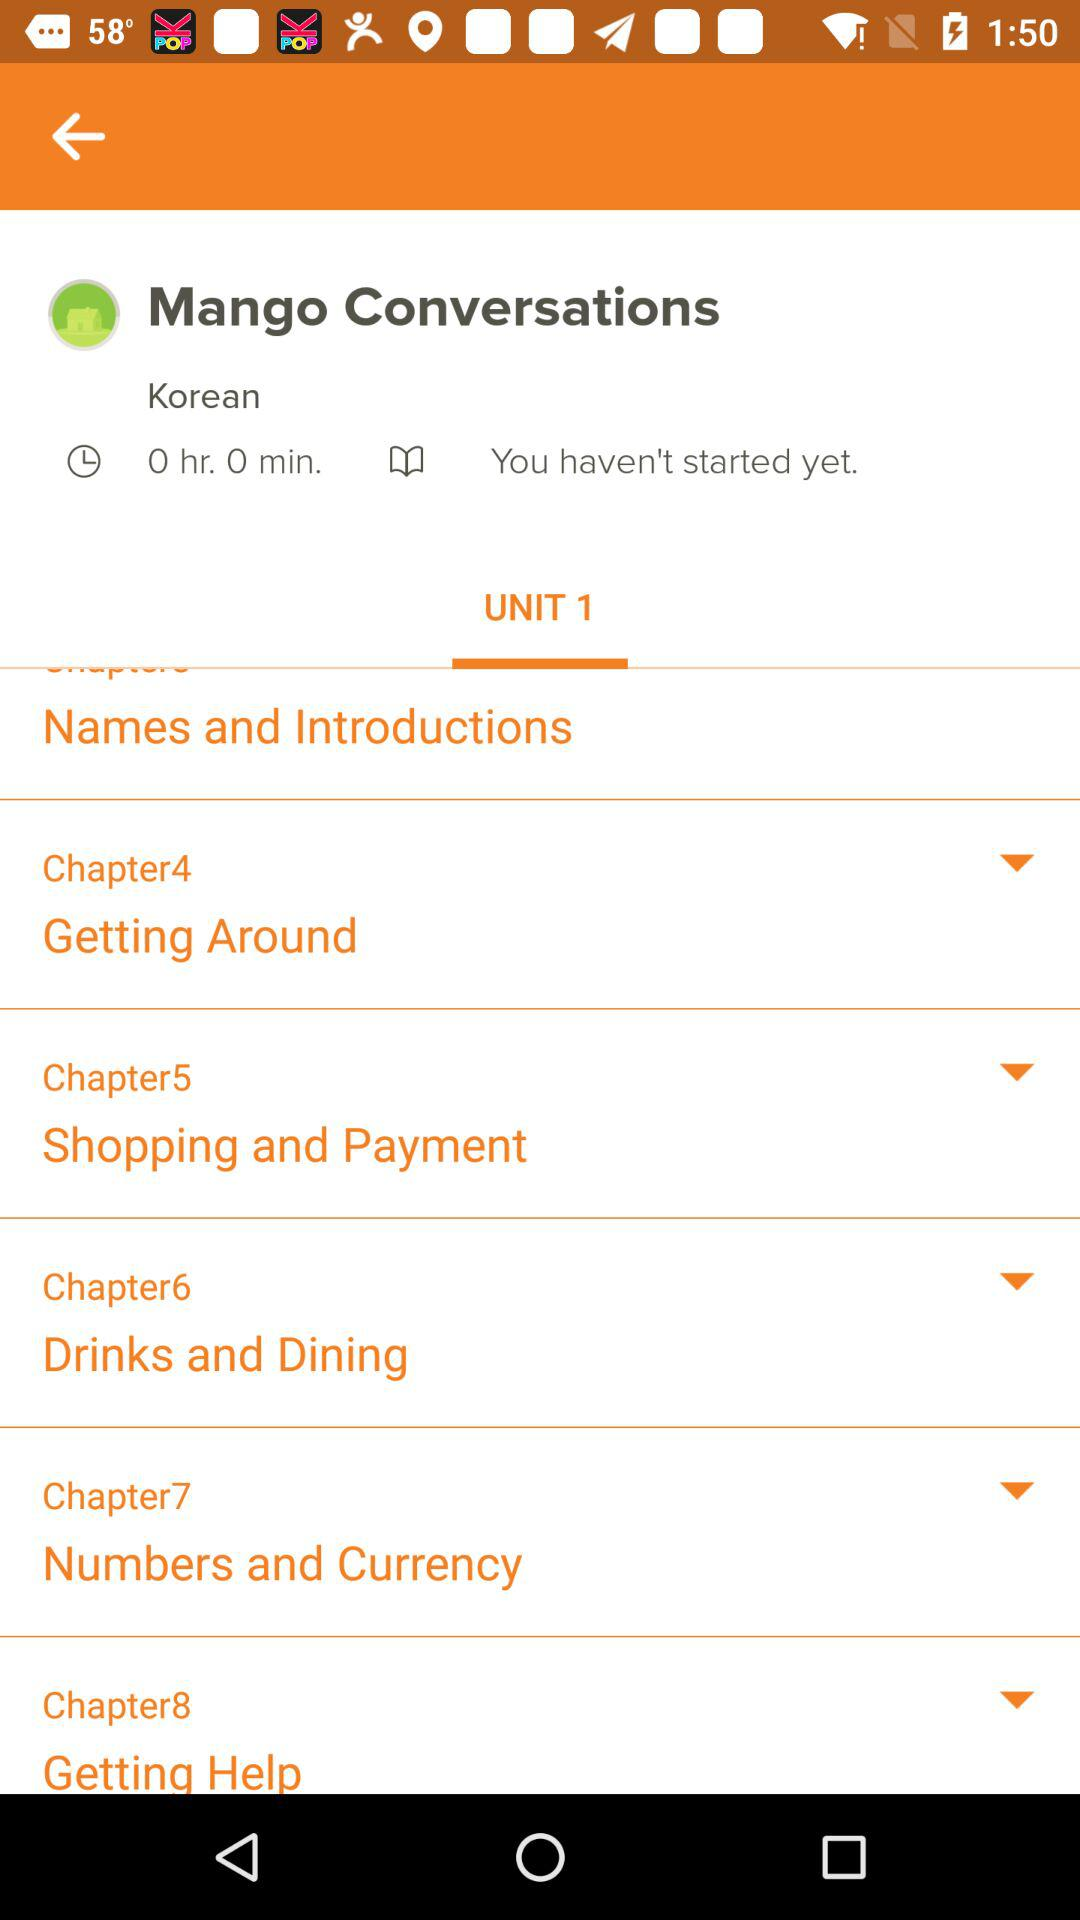How many chapters are there in the Korean course?
Answer the question using a single word or phrase. 8 